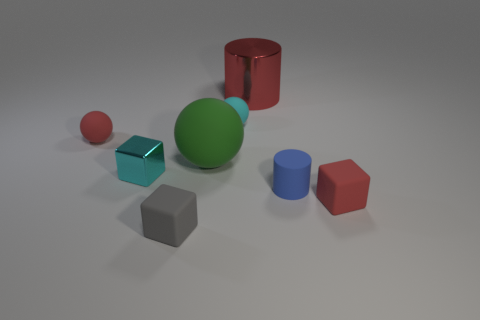Subtract all small spheres. How many spheres are left? 1 Add 2 gray blocks. How many objects exist? 10 Subtract all cylinders. How many objects are left? 6 Add 8 small gray matte cylinders. How many small gray matte cylinders exist? 8 Subtract 0 brown cubes. How many objects are left? 8 Subtract all small gray spheres. Subtract all tiny metallic cubes. How many objects are left? 7 Add 3 small matte cubes. How many small matte cubes are left? 5 